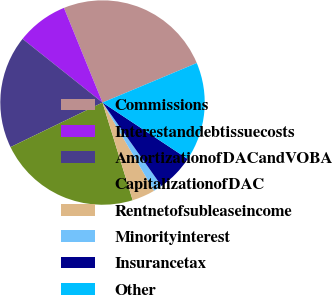Convert chart to OTSL. <chart><loc_0><loc_0><loc_500><loc_500><pie_chart><fcel>Commissions<fcel>Interestanddebtissuecosts<fcel>AmortizationofDACandVOBA<fcel>CapitalizationofDAC<fcel>Rentnetofsubleaseincome<fcel>Minorityinterest<fcel>Insurancetax<fcel>Other<nl><fcel>24.84%<fcel>8.14%<fcel>17.88%<fcel>22.59%<fcel>3.64%<fcel>1.39%<fcel>5.89%<fcel>15.63%<nl></chart> 